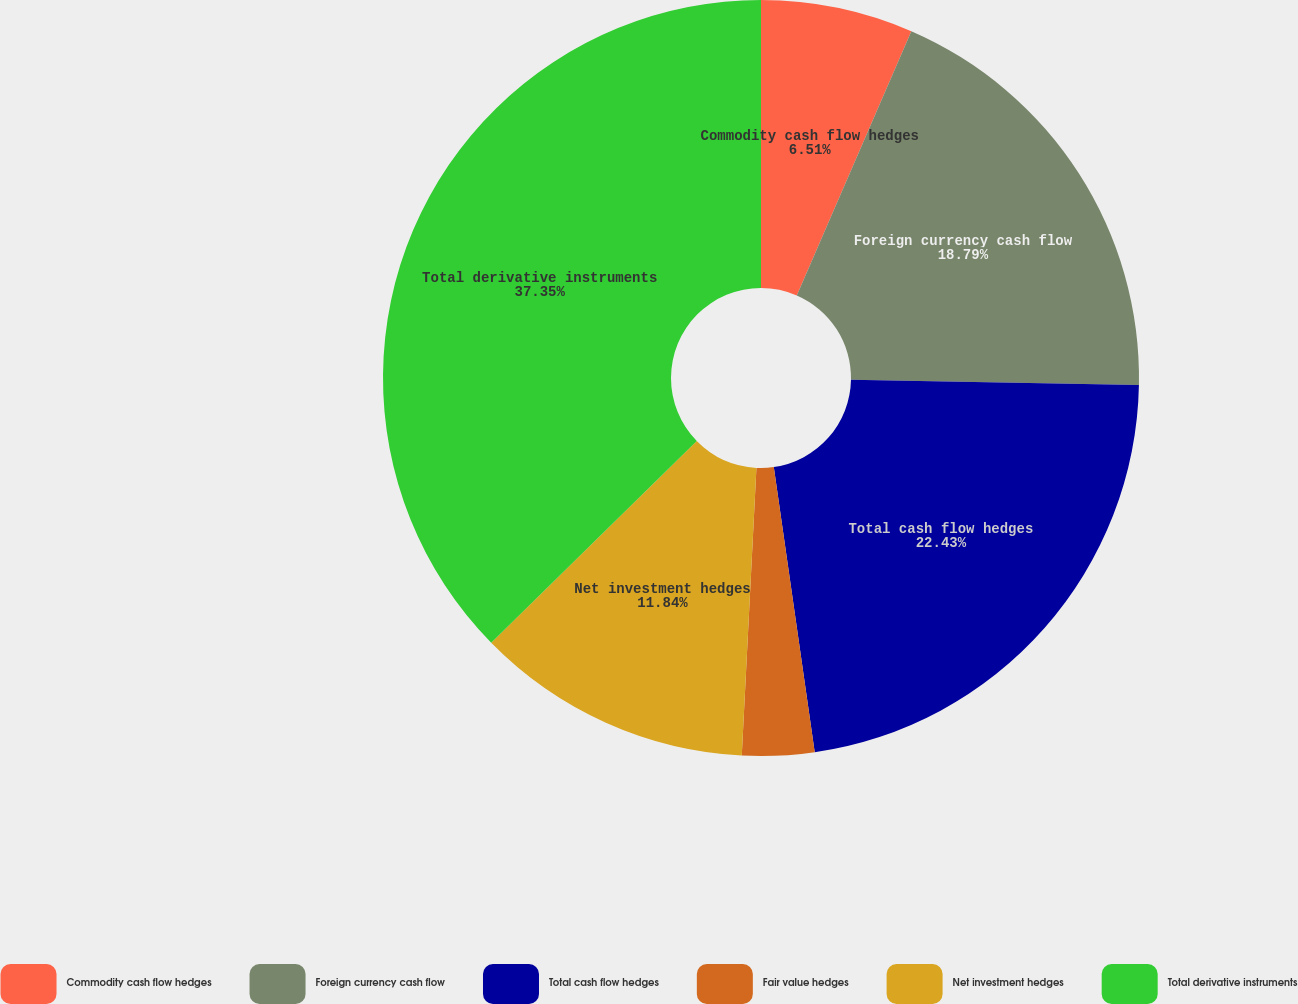Convert chart to OTSL. <chart><loc_0><loc_0><loc_500><loc_500><pie_chart><fcel>Commodity cash flow hedges<fcel>Foreign currency cash flow<fcel>Total cash flow hedges<fcel>Fair value hedges<fcel>Net investment hedges<fcel>Total derivative instruments<nl><fcel>6.51%<fcel>18.79%<fcel>22.43%<fcel>3.08%<fcel>11.84%<fcel>37.35%<nl></chart> 